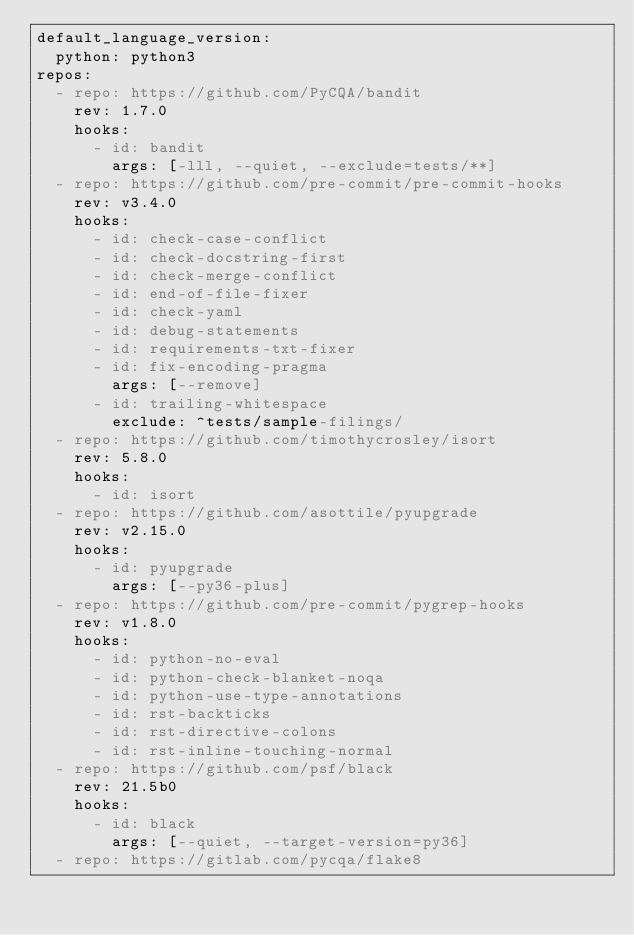Convert code to text. <code><loc_0><loc_0><loc_500><loc_500><_YAML_>default_language_version:
  python: python3
repos:
  - repo: https://github.com/PyCQA/bandit
    rev: 1.7.0
    hooks:
      - id: bandit
        args: [-lll, --quiet, --exclude=tests/**]
  - repo: https://github.com/pre-commit/pre-commit-hooks
    rev: v3.4.0
    hooks:
      - id: check-case-conflict
      - id: check-docstring-first
      - id: check-merge-conflict
      - id: end-of-file-fixer
      - id: check-yaml
      - id: debug-statements
      - id: requirements-txt-fixer
      - id: fix-encoding-pragma
        args: [--remove]
      - id: trailing-whitespace
        exclude: ^tests/sample-filings/
  - repo: https://github.com/timothycrosley/isort
    rev: 5.8.0
    hooks:
      - id: isort
  - repo: https://github.com/asottile/pyupgrade
    rev: v2.15.0
    hooks:
      - id: pyupgrade
        args: [--py36-plus]
  - repo: https://github.com/pre-commit/pygrep-hooks
    rev: v1.8.0
    hooks:
      - id: python-no-eval
      - id: python-check-blanket-noqa
      - id: python-use-type-annotations
      - id: rst-backticks
      - id: rst-directive-colons
      - id: rst-inline-touching-normal
  - repo: https://github.com/psf/black
    rev: 21.5b0
    hooks:
      - id: black
        args: [--quiet, --target-version=py36]
  - repo: https://gitlab.com/pycqa/flake8</code> 